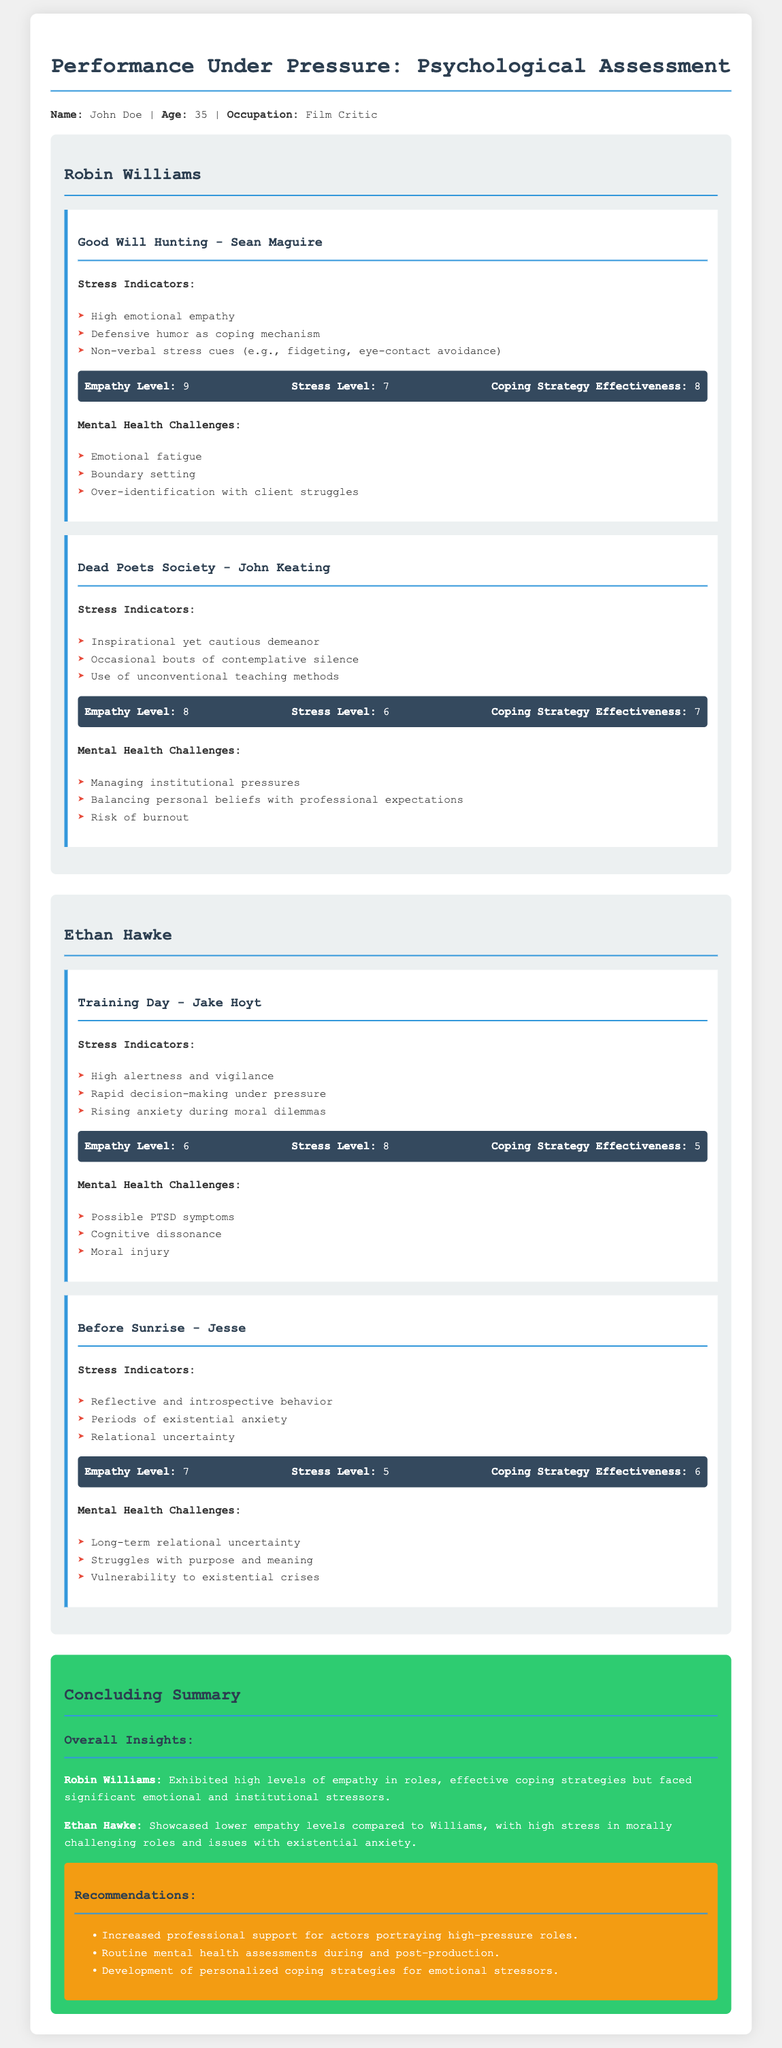what is the name of the first actor analyzed? The document begins with an analysis of Robin Williams, who is identified as the first actor.
Answer: Robin Williams what role did Robin Williams portray in "Good Will Hunting"? The document specifies that he played Sean Maguire in the film "Good Will Hunting."
Answer: Sean Maguire what is Ethan Hawke's empathy level in "Training Day"? The psychological assessment for "Training Day" indicates an empathy level of 6 for Ethan Hawke.
Answer: 6 what coping strategy effectiveness score did Robin Williams receive for "Dead Poets Society"? The coping strategy effectiveness score for Robin Williams in "Dead Poets Society" is listed as 7 in the document.
Answer: 7 which mental health challenge is mentioned for Ethan Hawke in "Training Day"? The document lists "Possible PTSD symptoms" as one of the mental health challenges for Ethan Hawke in "Training Day."
Answer: Possible PTSD symptoms how many movies are analyzed for each actor? The document analyzes two movies for each actor, Robin Williams and Ethan Hawke.
Answer: Two what was the stress level of Robin Williams in "Good Will Hunting"? According to the psychological assessment in the document, Robin Williams had a stress level of 7 in "Good Will Hunting."
Answer: 7 what is the overall insight on Ethan Hawke's empathy compared to Robin Williams? The document indicates that Ethan Hawke showcased lower empathy levels compared to Robin Williams.
Answer: Lower empathy levels what recommendation is made regarding actors portraying high-pressure roles? The document suggests that there should be increased professional support for actors portraying high-pressure roles.
Answer: Increased professional support 